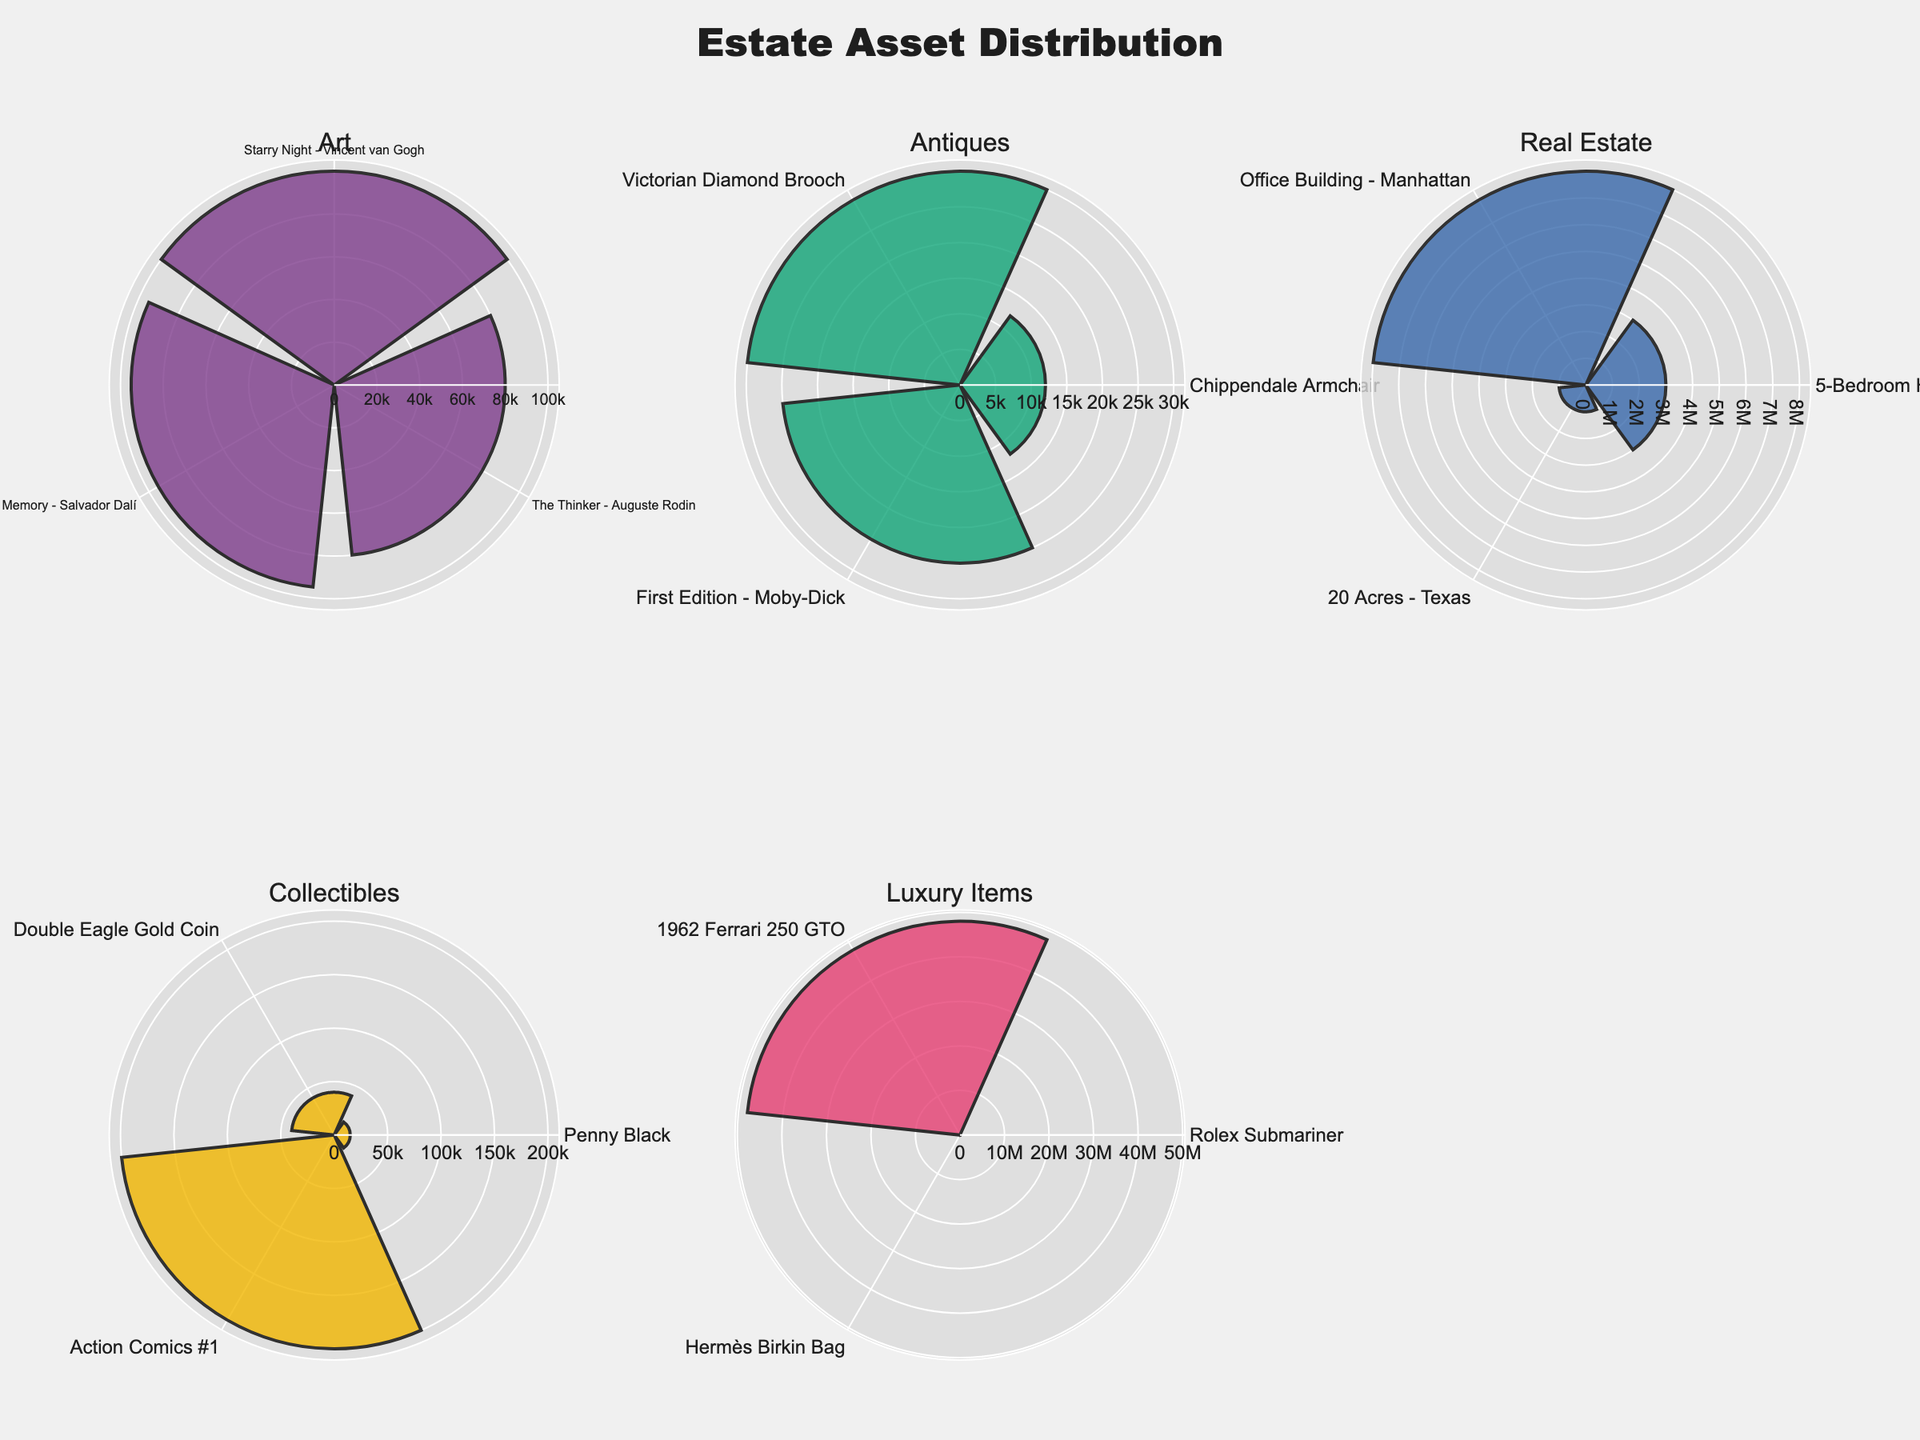What is the most valuable "Luxury Item" in the subplots? To find the most valuable Luxury Item, look at the values in the subplot for "Luxury Items". The item with the highest value is the 1962 Ferrari 250 GTO worth 48,000,000.
Answer: 1962 Ferrari 250 GTO How many categories are displayed in the subplots? Count the number of subplot titles. There are six categories displayed: "Art", "Antiques", "Real Estate", "Collectibles", "Luxury Items".
Answer: 5 Which category has the highest overall value of assets? Compare the total values for each category by summing up the values displayed in each subplot. Real Estate has the highest overall value with assets totaling 12,000,000.
Answer: Real Estate What is the combined value of all the "Art" items? Sum the values of all "Art" items from the "Art" subplot: 100,000 (Starry Night) + 80,000 (The Thinker) + 95,000 (The Persistence of Memory) = 275,000.
Answer: 275,000 Is "Real Estate" more valuable than "Luxury Items"? Yes, compare the total values from both subplots. Real Estate totals to 12,000,000 while Luxury Items total to 48,235,000.
Answer: No What is the least valuable "Antique" item? Examine the values in the "Antiques" subplot. The Chippendale Armchair with a value of 12,000 is the least valuable.
Answer: Chippendale Armchair What's the average value of the "Collectibles" items? There are three Collectibles items. Sum their values (15,000 for Penny Black + 40,000 for Double Eagle Gold Coin + 200,000 for Action Comics #1 = 255,000) and divide by the number of items (255,000 / 3 = 85,000).
Answer: 85,000 Which sub-category in "Real Estate" has the least value? Under Real Estate, compare the values of Residential (3,000,000), Commercial (8,000,000), and Land (1,000,000). Land has the least value.
Answer: Land 